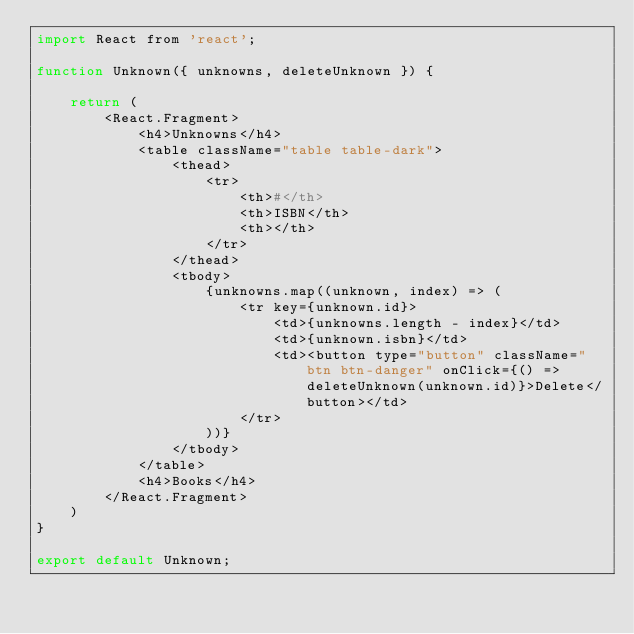<code> <loc_0><loc_0><loc_500><loc_500><_JavaScript_>import React from 'react';

function Unknown({ unknowns, deleteUnknown }) {

    return (
        <React.Fragment>
            <h4>Unknowns</h4>
            <table className="table table-dark">
                <thead>
                    <tr>
                        <th>#</th>
                        <th>ISBN</th>
                        <th></th>
                    </tr>
                </thead>
                <tbody>
                    {unknowns.map((unknown, index) => (
                        <tr key={unknown.id}>
                            <td>{unknowns.length - index}</td>
                            <td>{unknown.isbn}</td>
                            <td><button type="button" className="btn btn-danger" onClick={() => deleteUnknown(unknown.id)}>Delete</button></td>
                        </tr>
                    ))}
                </tbody>
            </table>
            <h4>Books</h4>
        </React.Fragment>
    )
}

export default Unknown;
</code> 